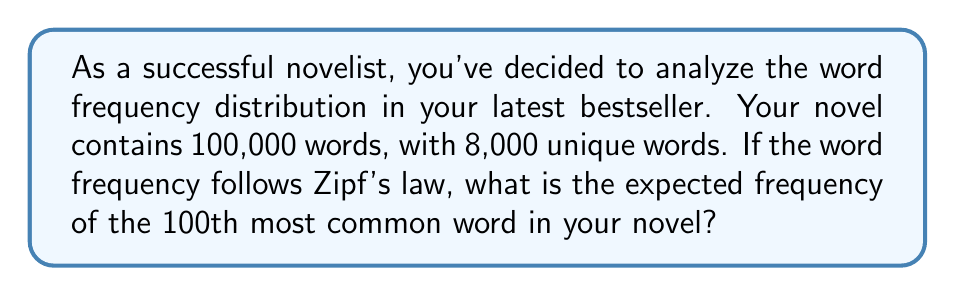What is the answer to this math problem? To solve this problem, we'll use Zipf's law and follow these steps:

1. Understand Zipf's law:
   Zipf's law states that the frequency of any word is inversely proportional to its rank in the frequency table. Mathematically, it can be expressed as:

   $$ f(k) = \frac{C}{k^s} $$

   Where:
   $f(k)$ is the frequency of the word with rank $k$
   $C$ is a constant (usually close to 0.1)
   $s$ is the value of the exponent (usually close to 1)

2. Determine the constant $C$:
   The most frequent word (rank 1) typically accounts for about 7% of all words in a text. So:

   $$ f(1) = 0.07 \times 100,000 = 7,000 $$

   $$ C = f(1) \times 1^s = 7,000 $$

3. Calculate the frequency of the 100th most common word:

   $$ f(100) = \frac{C}{100^s} = \frac{7,000}{100^1} = 70 $$

Therefore, the expected frequency of the 100th most common word in your novel is 70 occurrences.
Answer: 70 occurrences 